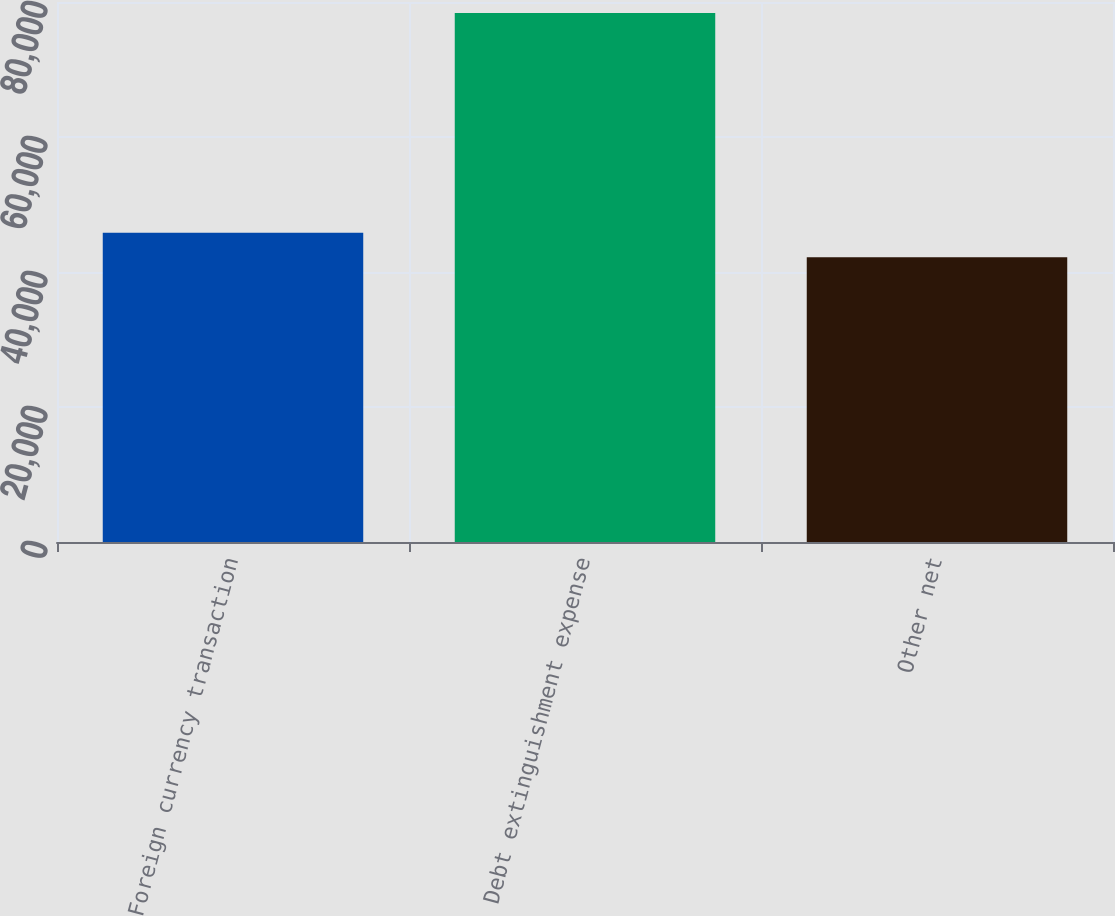Convert chart to OTSL. <chart><loc_0><loc_0><loc_500><loc_500><bar_chart><fcel>Foreign currency transaction<fcel>Debt extinguishment expense<fcel>Other net<nl><fcel>45805.1<fcel>78368<fcel>42187<nl></chart> 